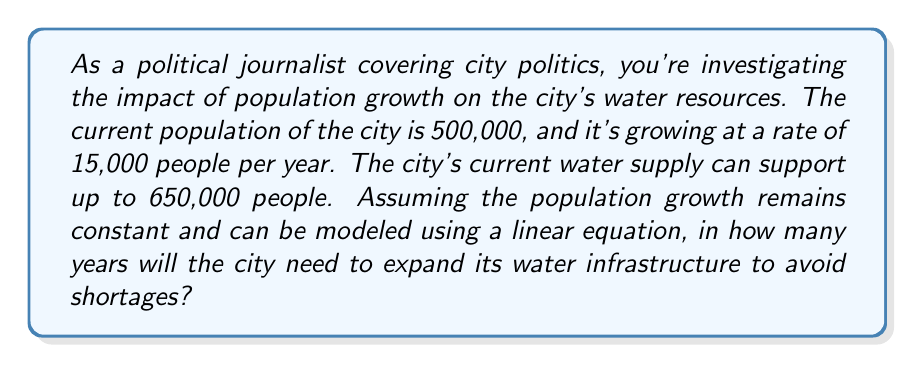Give your solution to this math problem. To solve this problem, we need to use a linear equation to model the population growth and determine when it will reach the maximum capacity of the current water supply.

Let's define our variables:
$t$ = time in years
$P(t)$ = population after $t$ years

We can write the linear equation for population growth as:
$$P(t) = 500,000 + 15,000t$$

We need to find $t$ when $P(t)$ equals 650,000:

$$650,000 = 500,000 + 15,000t$$

Subtracting 500,000 from both sides:
$$150,000 = 15,000t$$

Dividing both sides by 15,000:
$$10 = t$$

Therefore, it will take 10 years for the population to reach the maximum capacity of the current water supply.
Answer: The city will need to expand its water infrastructure in 10 years to avoid shortages. 